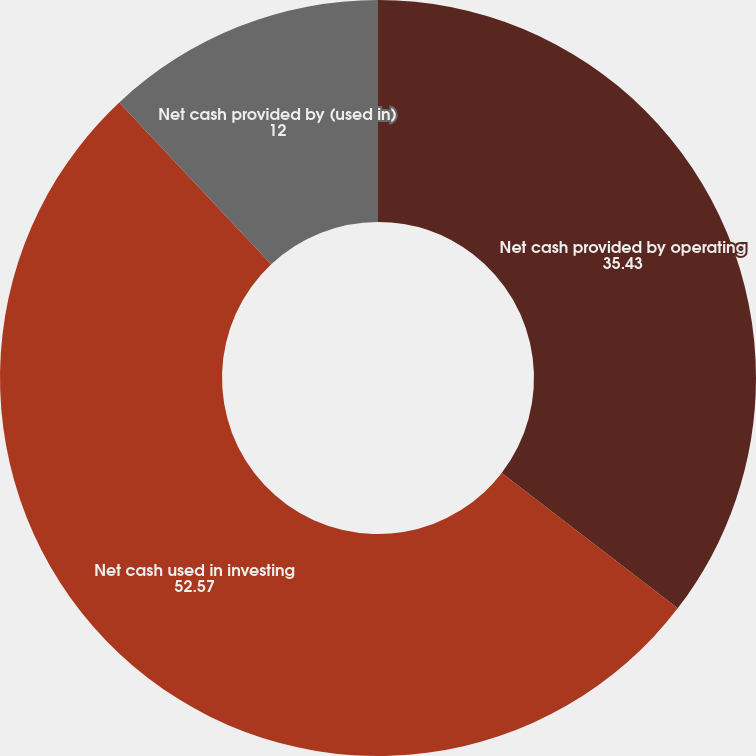Convert chart. <chart><loc_0><loc_0><loc_500><loc_500><pie_chart><fcel>Net cash provided by operating<fcel>Net cash used in investing<fcel>Net cash provided by (used in)<nl><fcel>35.43%<fcel>52.57%<fcel>12.0%<nl></chart> 